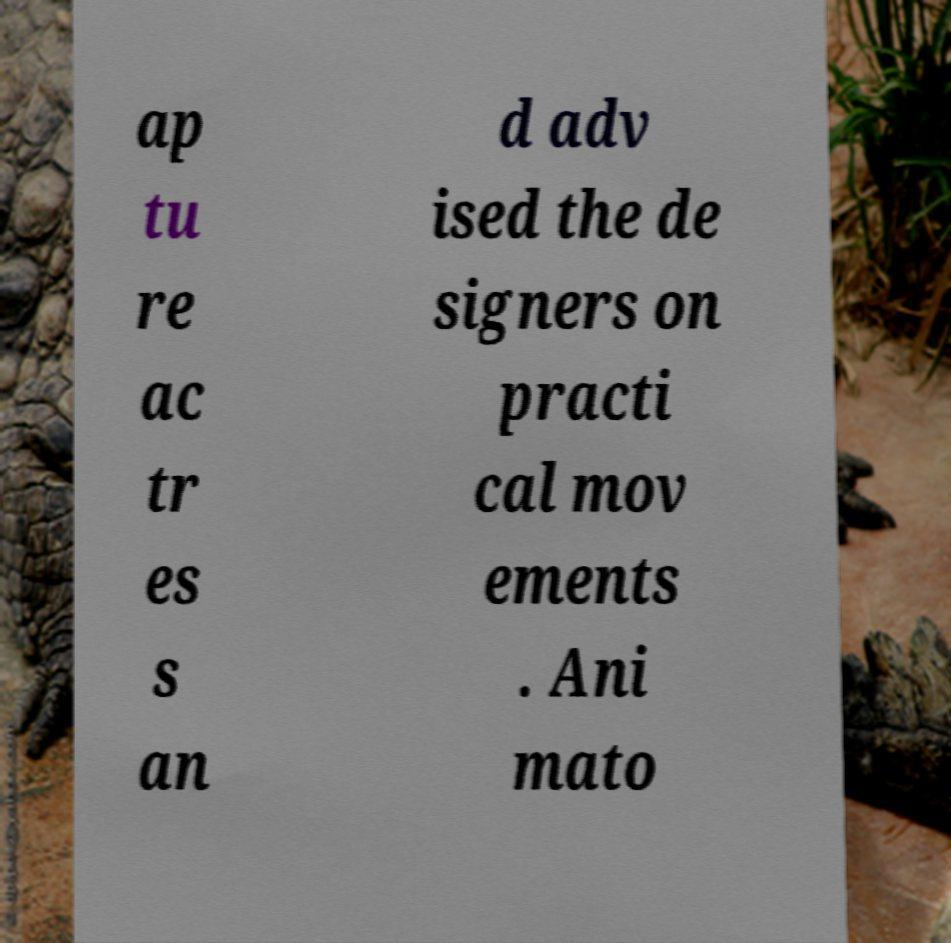Can you accurately transcribe the text from the provided image for me? ap tu re ac tr es s an d adv ised the de signers on practi cal mov ements . Ani mato 